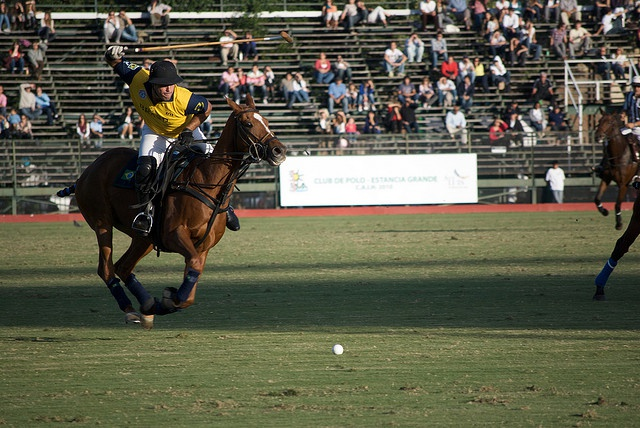Describe the objects in this image and their specific colors. I can see people in black, gray, darkgray, and lightgray tones, horse in black, maroon, and gray tones, people in black, gray, and olive tones, horse in black, maroon, and gray tones, and horse in black, darkgreen, gray, and navy tones in this image. 